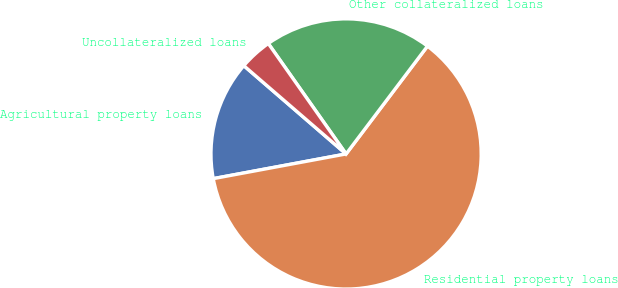Convert chart. <chart><loc_0><loc_0><loc_500><loc_500><pie_chart><fcel>Agricultural property loans<fcel>Residential property loans<fcel>Other collateralized loans<fcel>Uncollateralized loans<nl><fcel>14.26%<fcel>61.79%<fcel>20.06%<fcel>3.9%<nl></chart> 